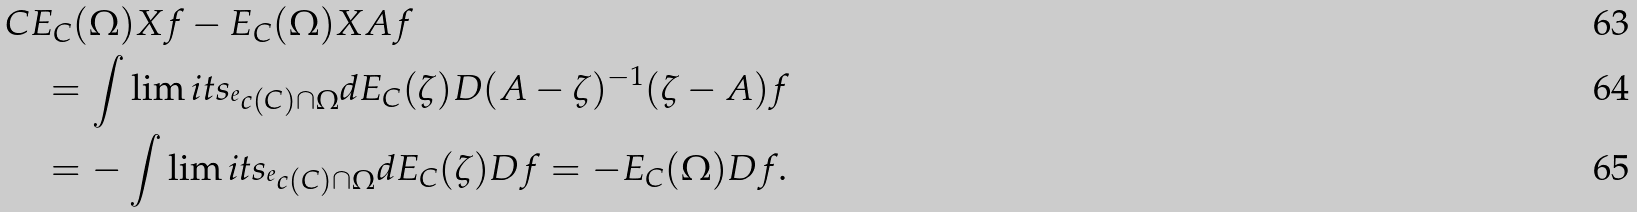Convert formula to latex. <formula><loc_0><loc_0><loc_500><loc_500>& { C E _ { C } ( \Omega ) X f - E _ { C } ( \Omega ) X A f } \\ & \quad = \int \lim i t s _ { ^ { e } c ( C ) \cap \Omega } d E _ { C } ( \zeta ) D ( A - \zeta ) ^ { - 1 } ( \zeta - A ) f \\ & \quad = - \int \lim i t s _ { ^ { e } c ( C ) \cap \Omega } d E _ { C } ( \zeta ) D f = - E _ { C } ( \Omega ) D f .</formula> 